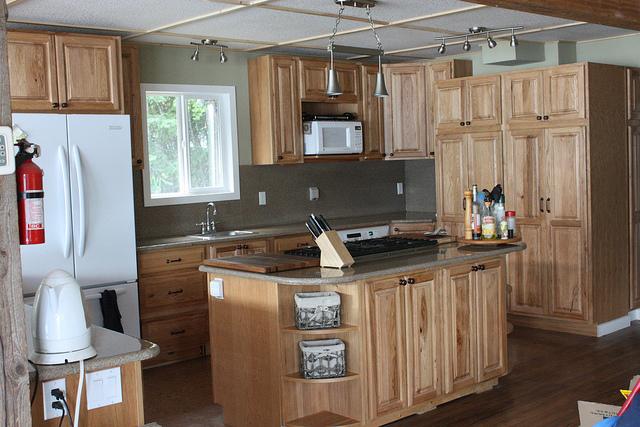Is this room still under construction?
Keep it brief. No. What kind of stove is pictured?
Answer briefly. Electric. Where is kettle?
Concise answer only. Counter. Are there knives on the counter?
Short answer required. Yes. How many doors are on the fridge?
Quick response, please. 3. Is there a fire extinguisher in the picture?
Give a very brief answer. Yes. Is this kitchen dirty?
Concise answer only. No. 